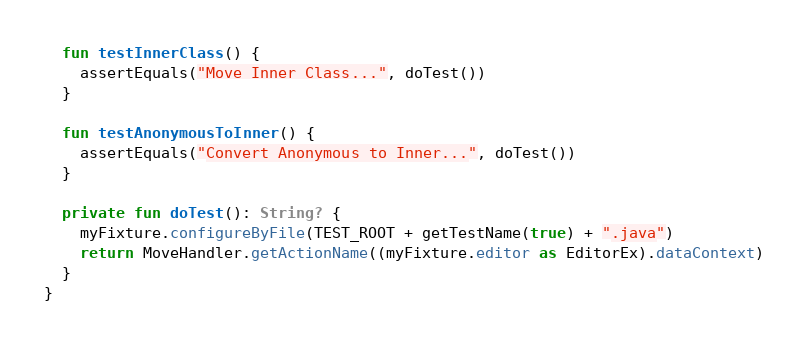Convert code to text. <code><loc_0><loc_0><loc_500><loc_500><_Kotlin_>
  fun testInnerClass() {
    assertEquals("Move Inner Class...", doTest())
  }

  fun testAnonymousToInner() {
    assertEquals("Convert Anonymous to Inner...", doTest())
  }

  private fun doTest(): String? {
    myFixture.configureByFile(TEST_ROOT + getTestName(true) + ".java")
    return MoveHandler.getActionName((myFixture.editor as EditorEx).dataContext)
  }
}</code> 